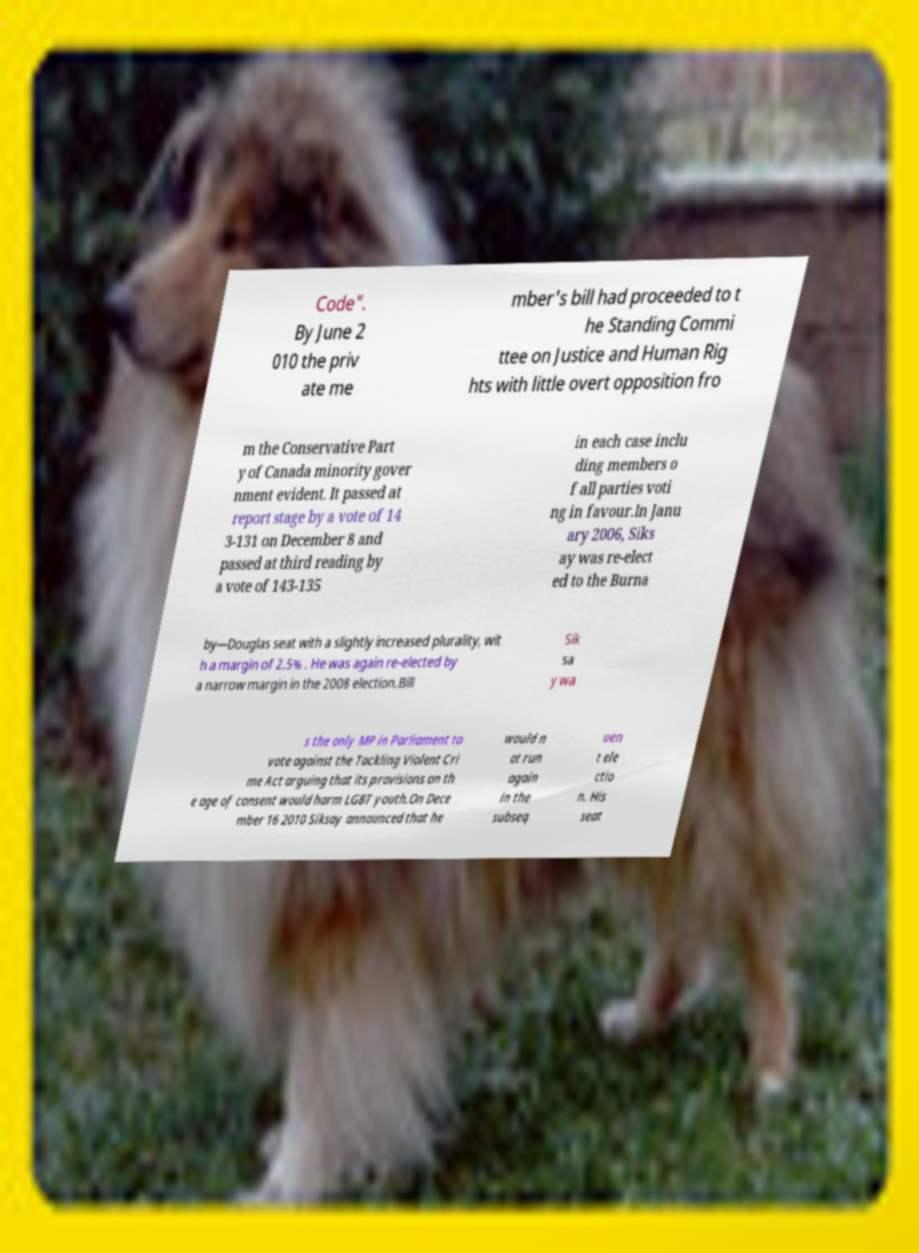Please identify and transcribe the text found in this image. Code". By June 2 010 the priv ate me mber's bill had proceeded to t he Standing Commi ttee on Justice and Human Rig hts with little overt opposition fro m the Conservative Part y of Canada minority gover nment evident. It passed at report stage by a vote of 14 3-131 on December 8 and passed at third reading by a vote of 143-135 in each case inclu ding members o f all parties voti ng in favour.In Janu ary 2006, Siks ay was re-elect ed to the Burna by—Douglas seat with a slightly increased plurality, wit h a margin of 2.5% . He was again re-elected by a narrow margin in the 2008 election.Bill Sik sa y wa s the only MP in Parliament to vote against the Tackling Violent Cri me Act arguing that its provisions on th e age of consent would harm LGBT youth.On Dece mber 16 2010 Siksay announced that he would n ot run again in the subseq uen t ele ctio n. His seat 